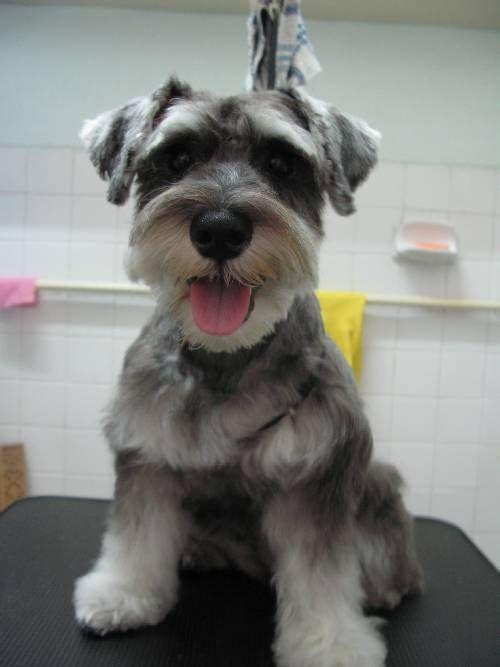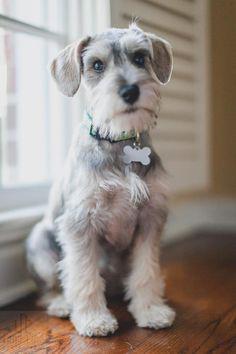The first image is the image on the left, the second image is the image on the right. For the images displayed, is the sentence "One of the images contains a dog with only the head showing." factually correct? Answer yes or no. No. 